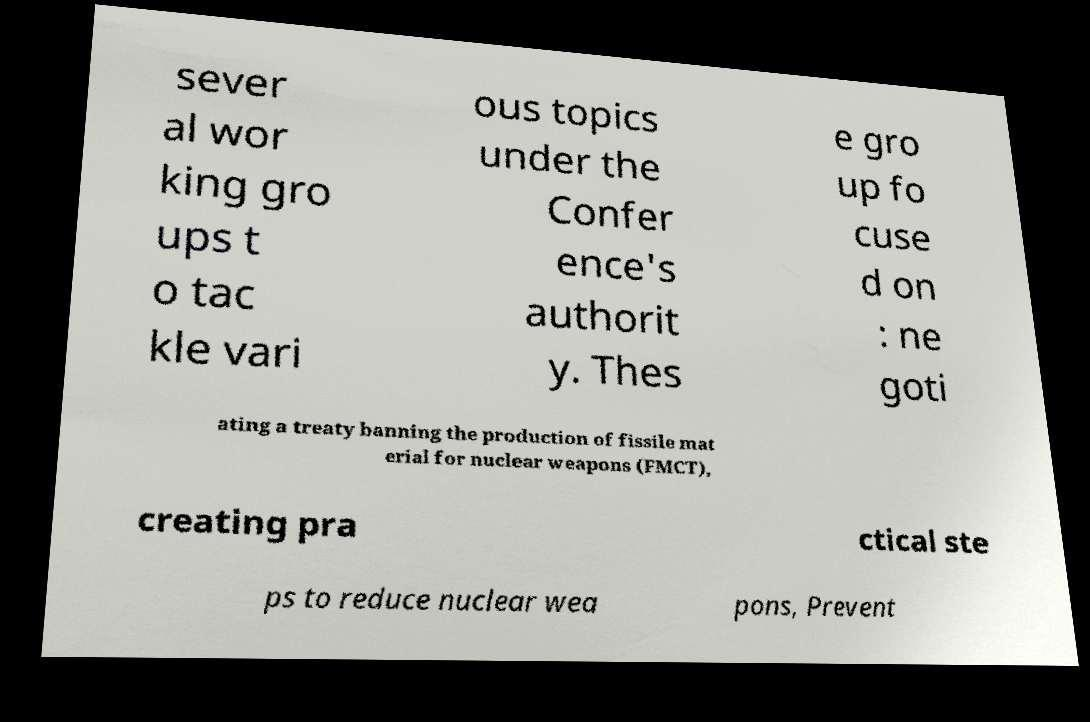For documentation purposes, I need the text within this image transcribed. Could you provide that? sever al wor king gro ups t o tac kle vari ous topics under the Confer ence's authorit y. Thes e gro up fo cuse d on : ne goti ating a treaty banning the production of fissile mat erial for nuclear weapons (FMCT), creating pra ctical ste ps to reduce nuclear wea pons, Prevent 